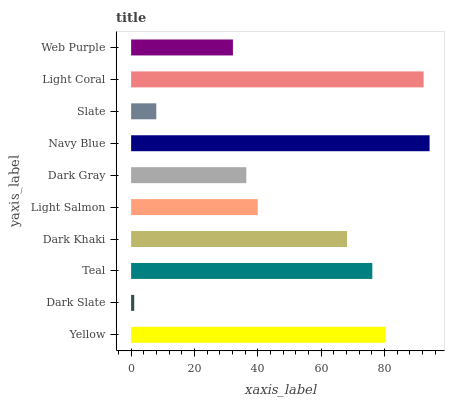Is Dark Slate the minimum?
Answer yes or no. Yes. Is Navy Blue the maximum?
Answer yes or no. Yes. Is Teal the minimum?
Answer yes or no. No. Is Teal the maximum?
Answer yes or no. No. Is Teal greater than Dark Slate?
Answer yes or no. Yes. Is Dark Slate less than Teal?
Answer yes or no. Yes. Is Dark Slate greater than Teal?
Answer yes or no. No. Is Teal less than Dark Slate?
Answer yes or no. No. Is Dark Khaki the high median?
Answer yes or no. Yes. Is Light Salmon the low median?
Answer yes or no. Yes. Is Teal the high median?
Answer yes or no. No. Is Dark Slate the low median?
Answer yes or no. No. 